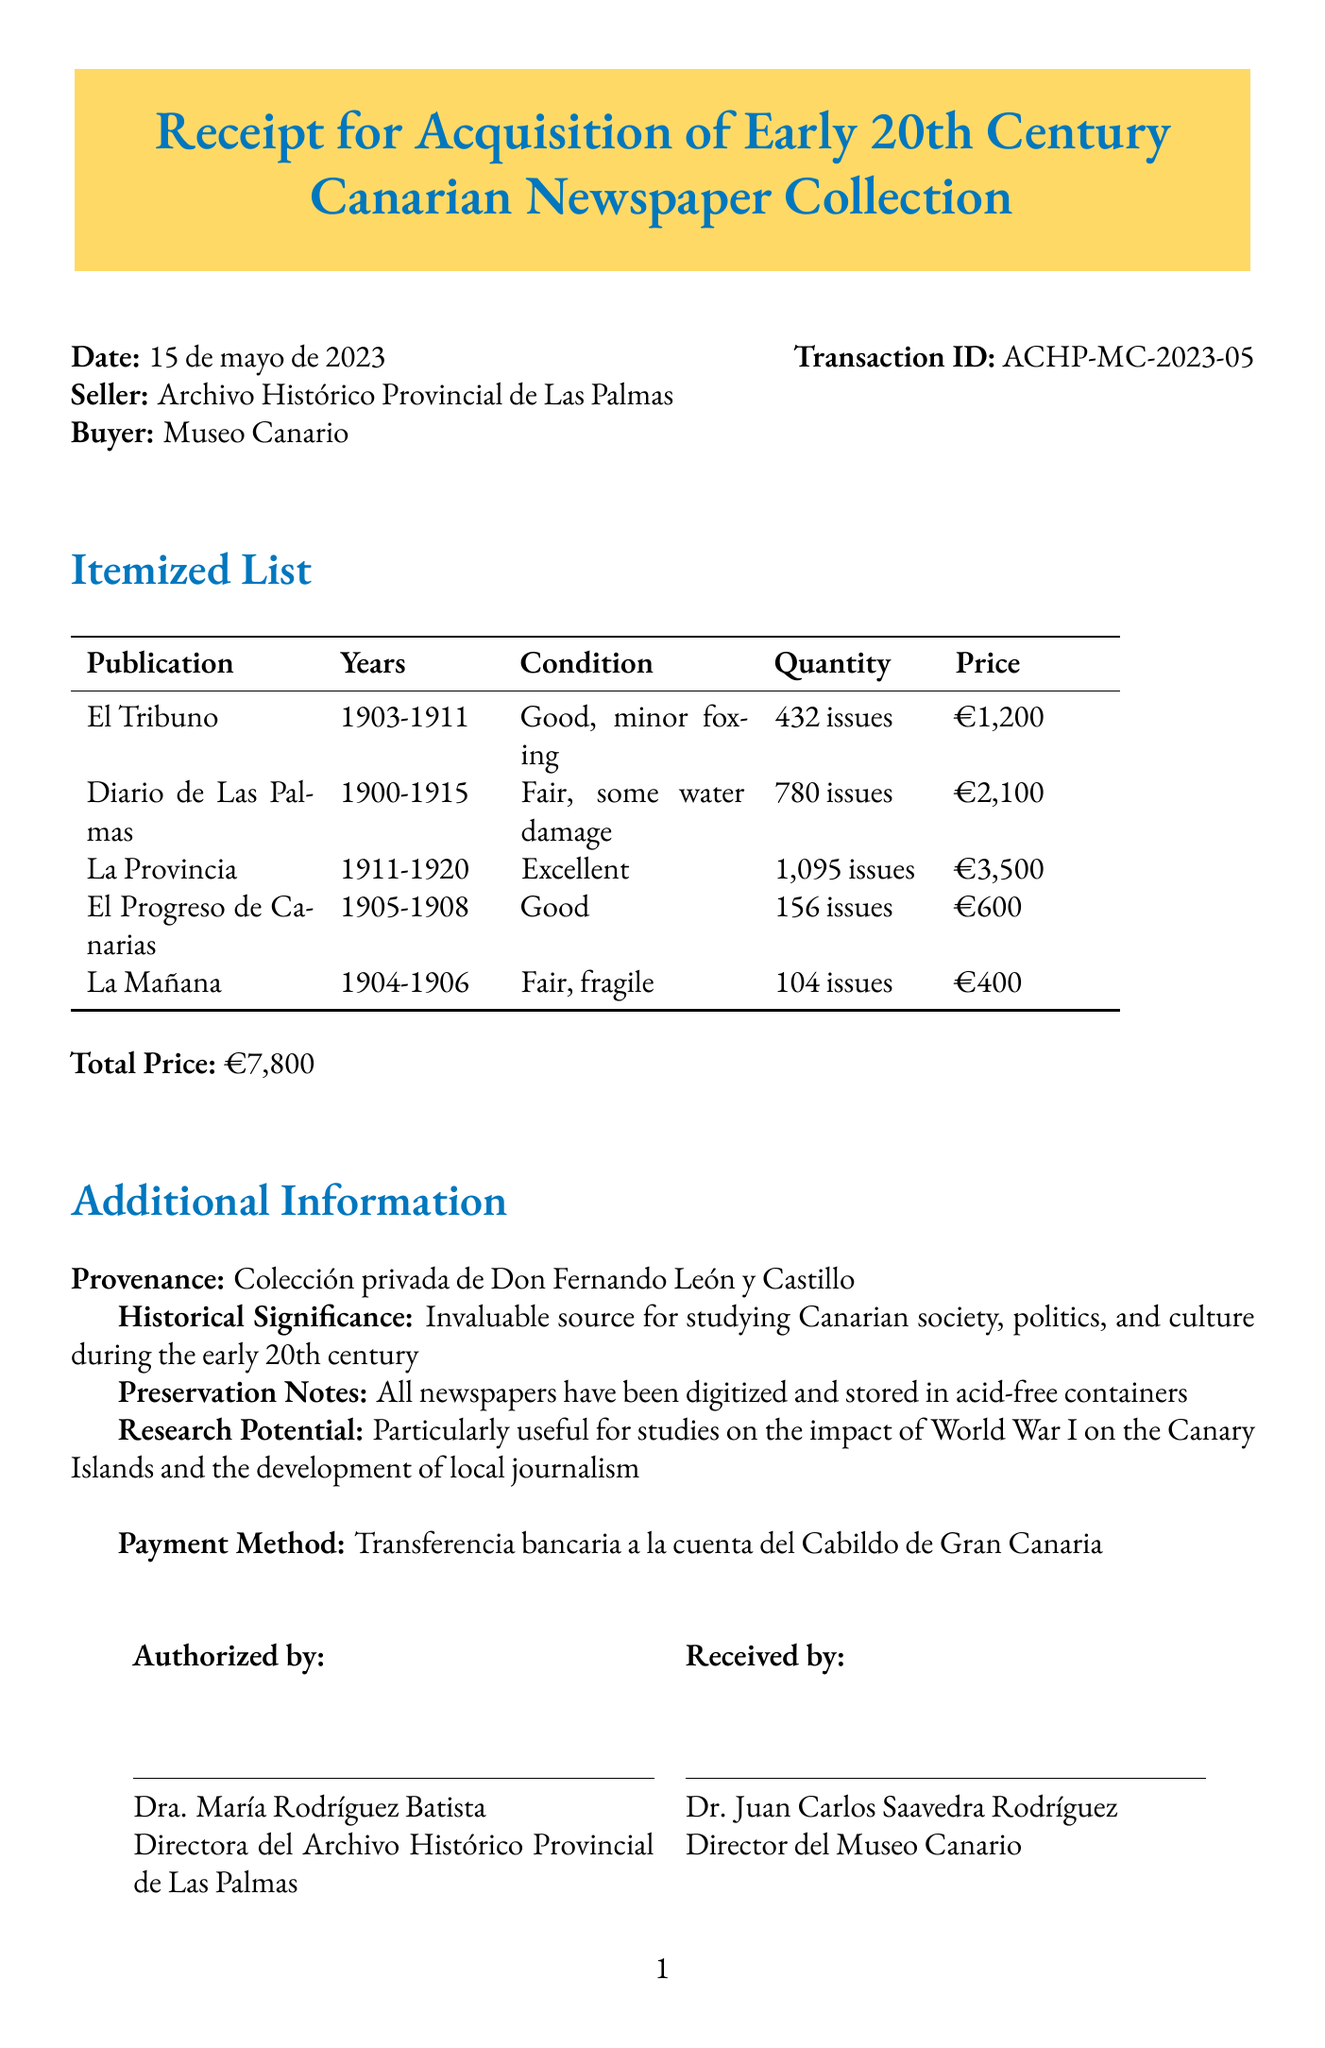What is the transaction ID? The transaction ID is specified in the header section of the receipt, where it is labeled as "Transaction ID".
Answer: ACHP-MC-2023-05 Who is the buyer? The buyer is mentioned in the receipt header where it states the name of the organization purchasing the newspapers.
Answer: Museo Canario How many issues of "La Provincia" were acquired? The number of issues is specified in the itemized list for "La Provincia", which details the quantity purchased.
Answer: 1,095 issues What is the total price of the collection? The total price is clearly indicated towards the end of the receipt, summarizing the overall cost of the acquisitions.
Answer: €7,800 What is the condition of "Diario de Las Palmas"? The condition of each publication is listed in the itemized section and specifically describes the state of "Diario de Las Palmas".
Answer: Fair, some water damage When was the receipt issued? The date of the transaction is stated in the header section, providing the specific day it was created.
Answer: 15 de mayo de 2023 Who authorized the transaction? The authorized person's name is presented at the bottom of the receipt, indicating who approved this transaction.
Answer: Dra. María Rodríguez Batista What is the provenance of the collection? The provenance is detailed under the additional information section, revealing the origin of the collection.
Answer: Colección privada de Don Fernando León y Castillo How many publications are listed in the itemized list? By counting the entries in the itemized list, we can determine the total number of publications included on the receipt.
Answer: 5 publications 